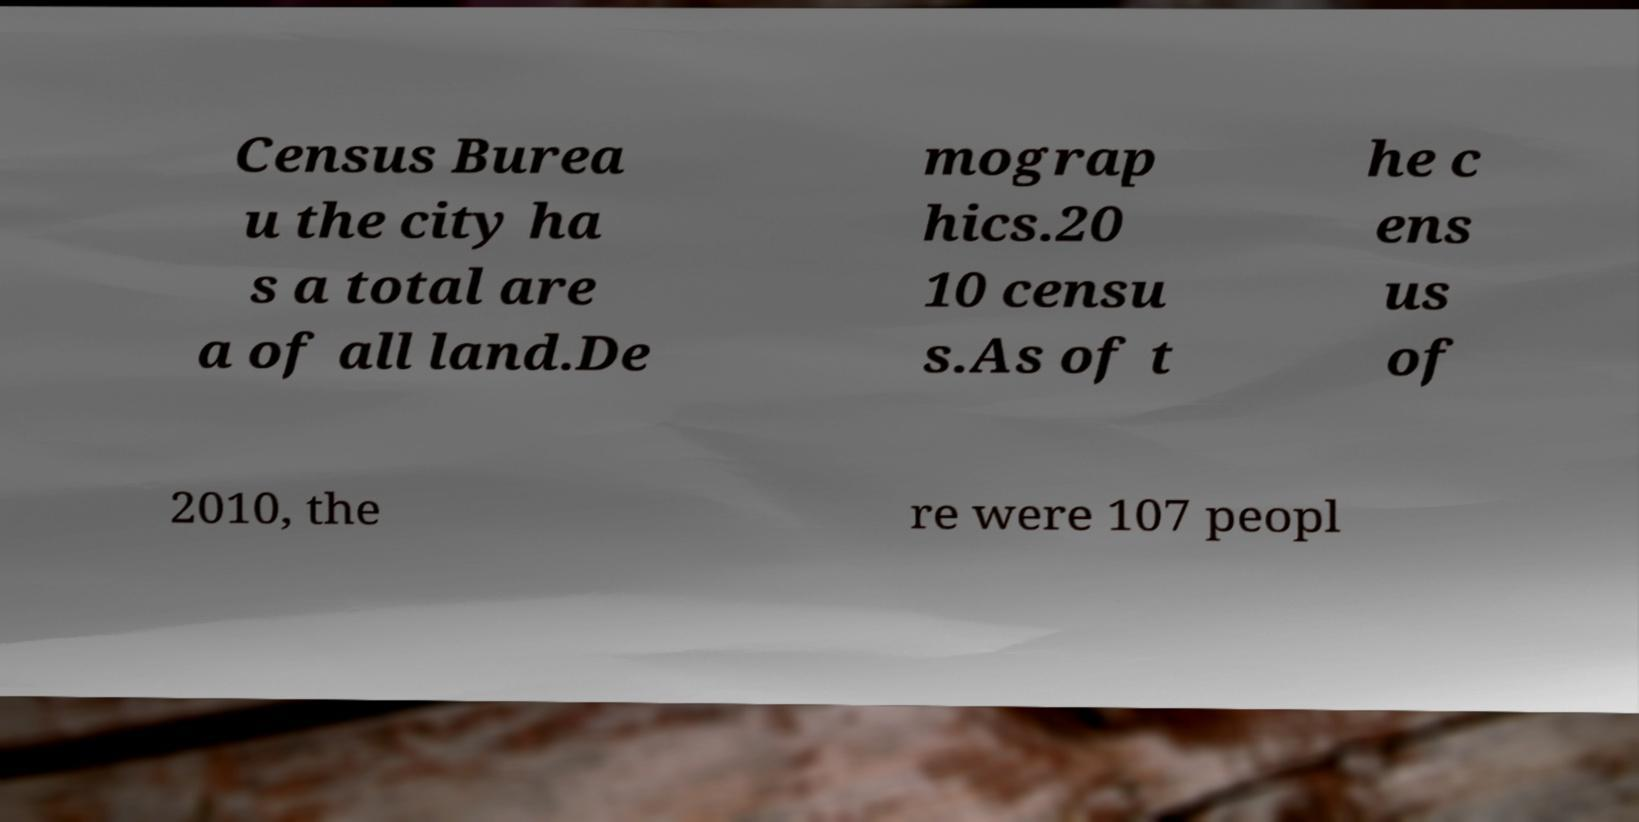Could you extract and type out the text from this image? Census Burea u the city ha s a total are a of all land.De mograp hics.20 10 censu s.As of t he c ens us of 2010, the re were 107 peopl 